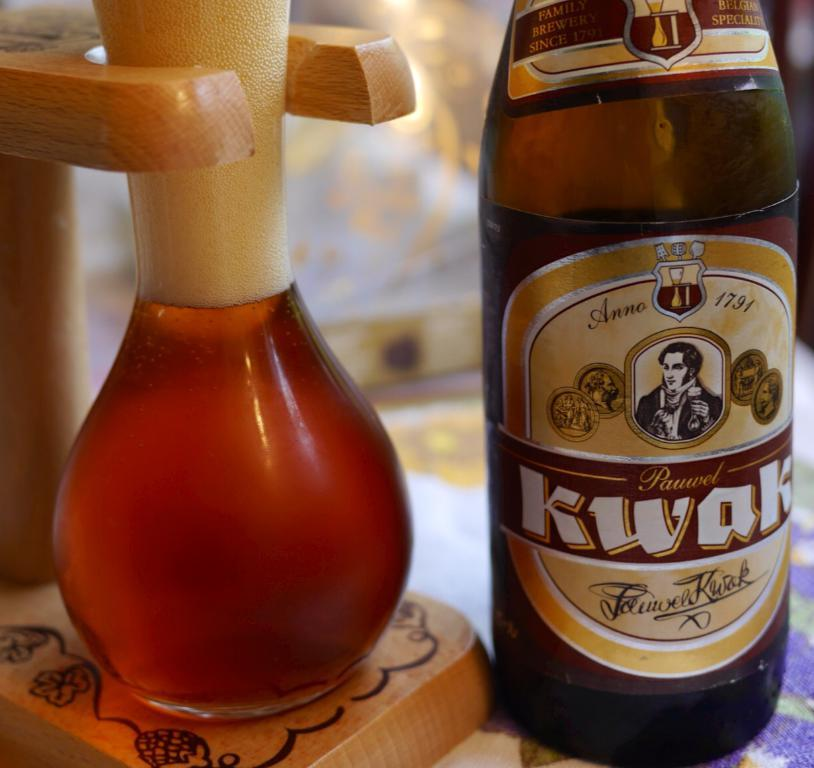<image>
Write a terse but informative summary of the picture. A bottle of Kwak is next to a bottle full of liquid. 